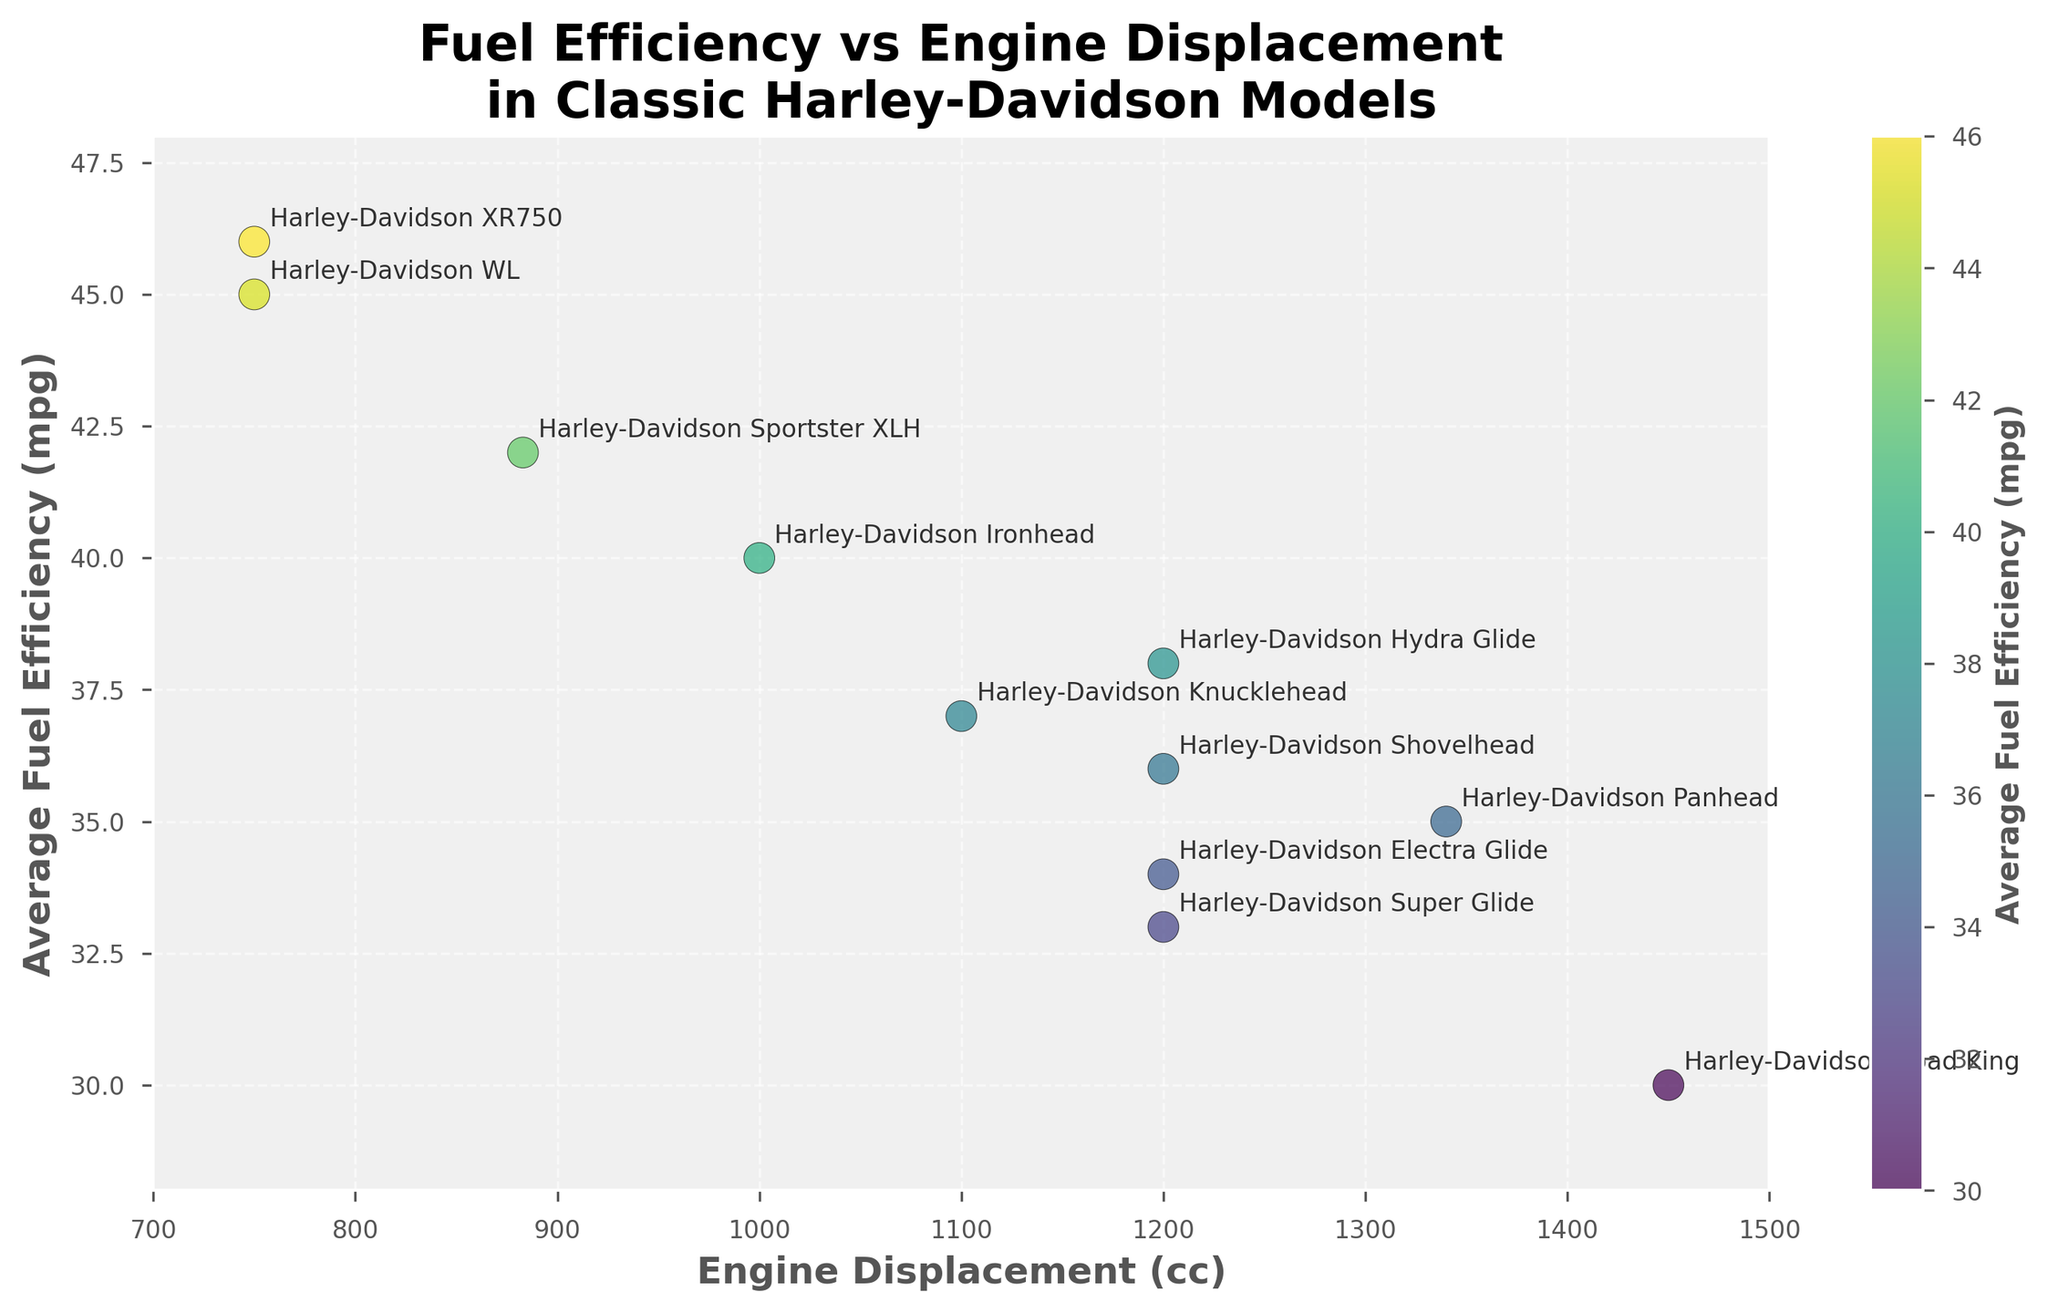What is the title of the plot? The title is written at the top of the plot.
Answer: Fuel Efficiency vs Engine Displacement in Classic Harley-Davidson Models How many data points are plotted in the figure? Count the number of scatter points in the graph.
Answer: 11 Which model has the highest average fuel efficiency? The XR750 is located at the top of the graph at (750, 46), representing the highest average fuel efficiency.
Answer: Harley-Davidson XR750 What is the average fuel efficiency of the Harley-Davidson Sportster XLH? Find the location of the Sportster XLH on the plot; it's located at (883, 42).
Answer: 42 mpg Which model has the largest engine displacement? The Road King is the furthest point to the right on the chart at (1450, 30).
Answer: Harley-Davidson Road King Which model has the lowest average fuel efficiency? The Super Glide is at the bottom of the chart at (1200, 33).
Answer: Harley-Davidson Super Glide Is the average fuel efficiency of the Harley-Davidson Panhead greater or less than that of the Harley-Davidson Shovelhead? Locate the two models on the graph: Panhead (1340, 35) and Shovelhead (1200, 36). Compare the y-values.
Answer: Less What is the engine displacement of the Harley-Davidson WL? The WL is marked at (750, 45) on the graph.
Answer: 750 cc How many models have an average fuel efficiency equal to or greater than 40 mpg? Count the points above or equal to 40 along the y-axis. These include Sportster XLH, Ironhead, WL, and XR750.
Answer: 4 Which model has a higher average fuel efficiency: the Hydra Glide or the Electra Glide? Compare their positions on the y-axis: Hydra Glide (38) and Electra Glide (34).
Answer: Harley-Davidson Hydra Glide 